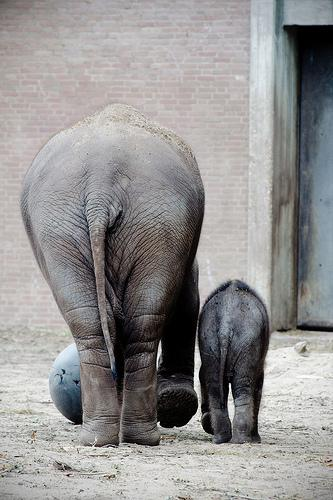Question: what animal is seen in the picture?
Choices:
A. Cow.
B. Horse.
C. Elephant.
D. Cat.
Answer with the letter. Answer: C Question: what are the elephants doing?
Choices:
A. Eating.
B. Sleeping.
C. Walking.
D. Playing.
Answer with the letter. Answer: C Question: how many elephants are in the photo?
Choices:
A. Three.
B. One.
C. Two.
D. Five.
Answer with the letter. Answer: C Question: what are the elephants walking towards?
Choices:
A. Trees.
B. Ball.
C. Water.
D. Barn.
Answer with the letter. Answer: B Question: what color are the elephants?
Choices:
A. White.
B. Grey.
C. Light.
D. Dark.
Answer with the letter. Answer: B 